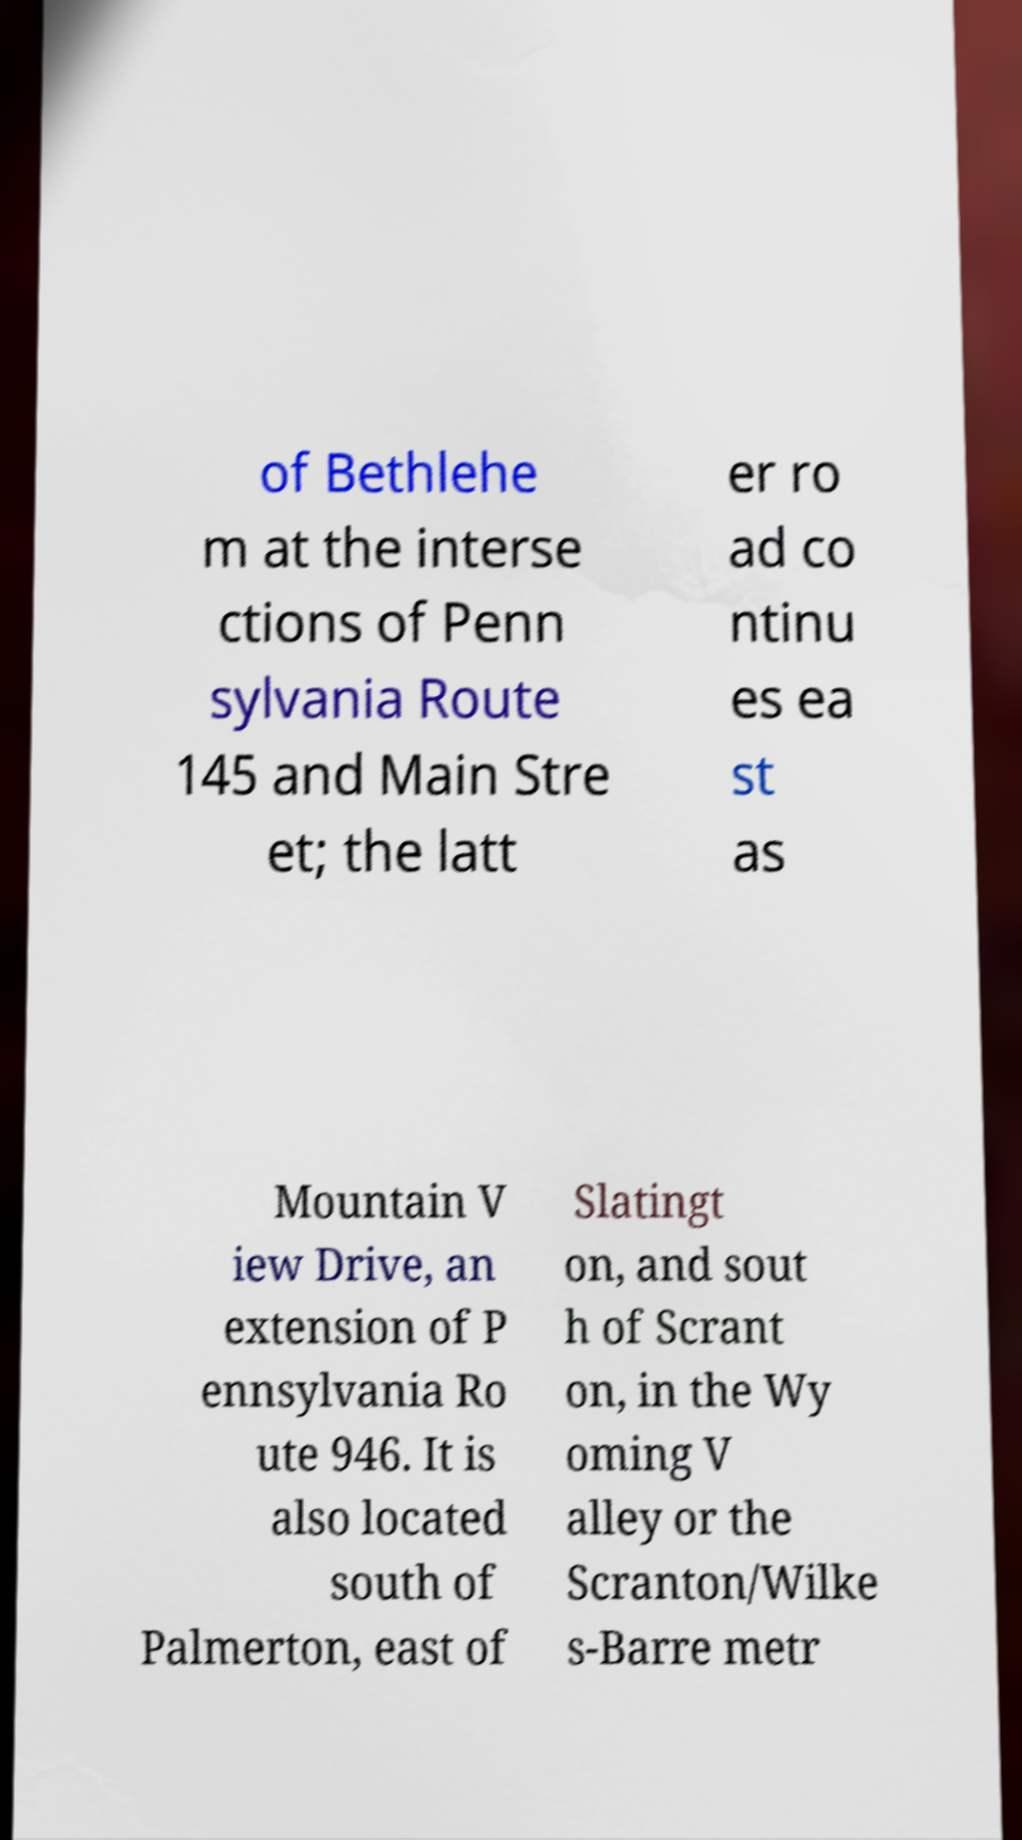There's text embedded in this image that I need extracted. Can you transcribe it verbatim? of Bethlehe m at the interse ctions of Penn sylvania Route 145 and Main Stre et; the latt er ro ad co ntinu es ea st as Mountain V iew Drive, an extension of P ennsylvania Ro ute 946. It is also located south of Palmerton, east of Slatingt on, and sout h of Scrant on, in the Wy oming V alley or the Scranton/Wilke s-Barre metr 